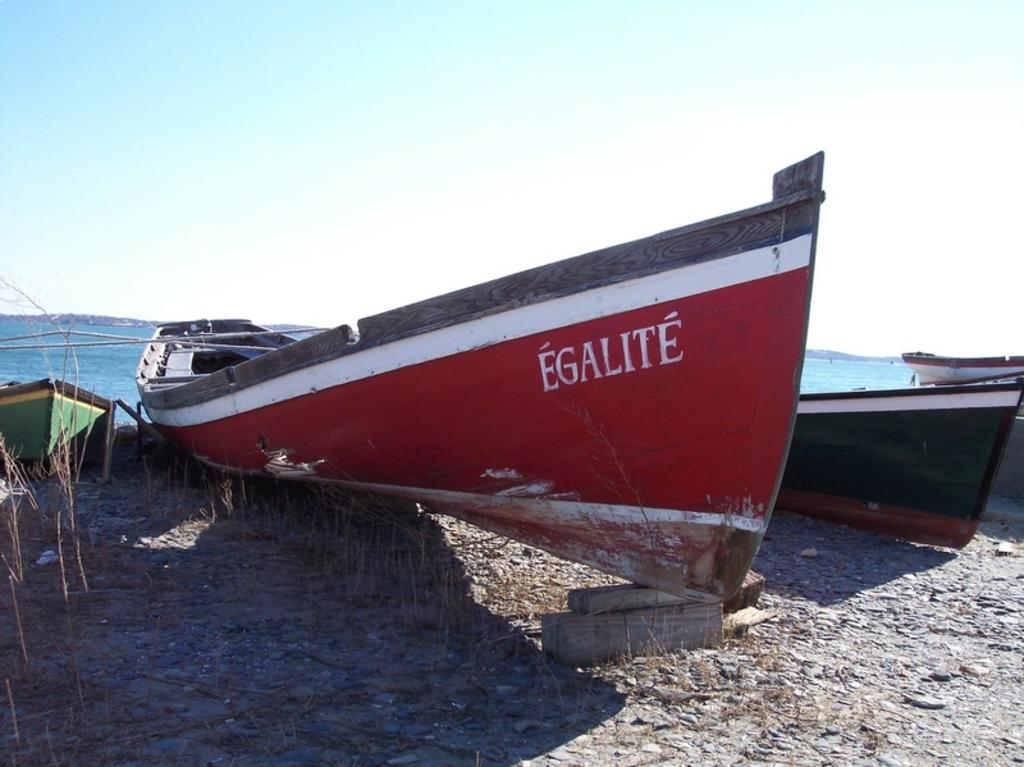What type of vehicles can be seen in the image? There are boats in the image. What is the primary setting in which the boats are located? There is water visible in the background of the image. What type of corn can be seen growing on the boats in the image? There is no corn present in the image; it features boats on water. 